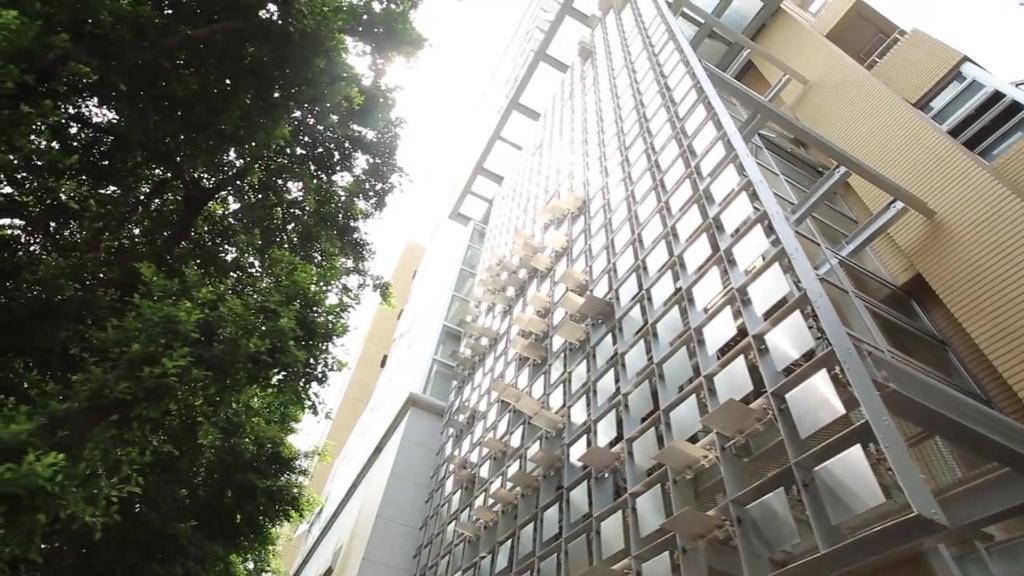Describe this image in one or two sentences. In this image we can see a building and a tree. The sky is in white color. 